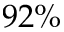Convert formula to latex. <formula><loc_0><loc_0><loc_500><loc_500>9 2 \%</formula> 